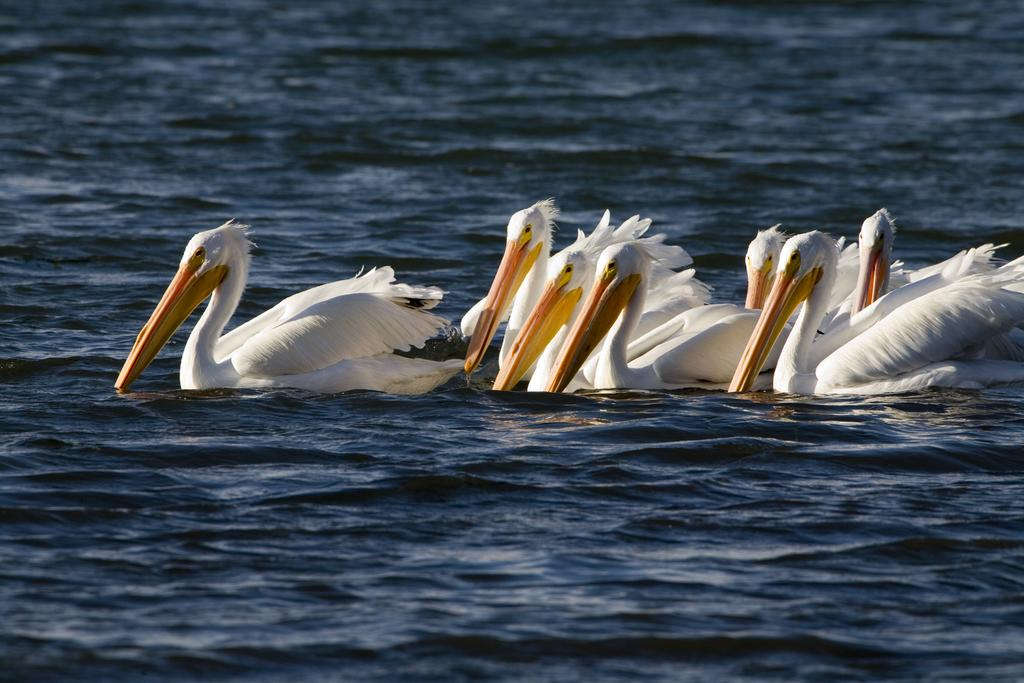What type of animals can be seen in the image? There are birds in the image. Where are the birds located? The birds are on the water. What color are the birds? The birds are white in color. What is visible in the image besides the birds? There is water visible in the image. What type of tax is being discussed by the birds in the image? There is no indication in the image that the birds are discussing any taxes, as birds do not have the ability to discuss taxes. 